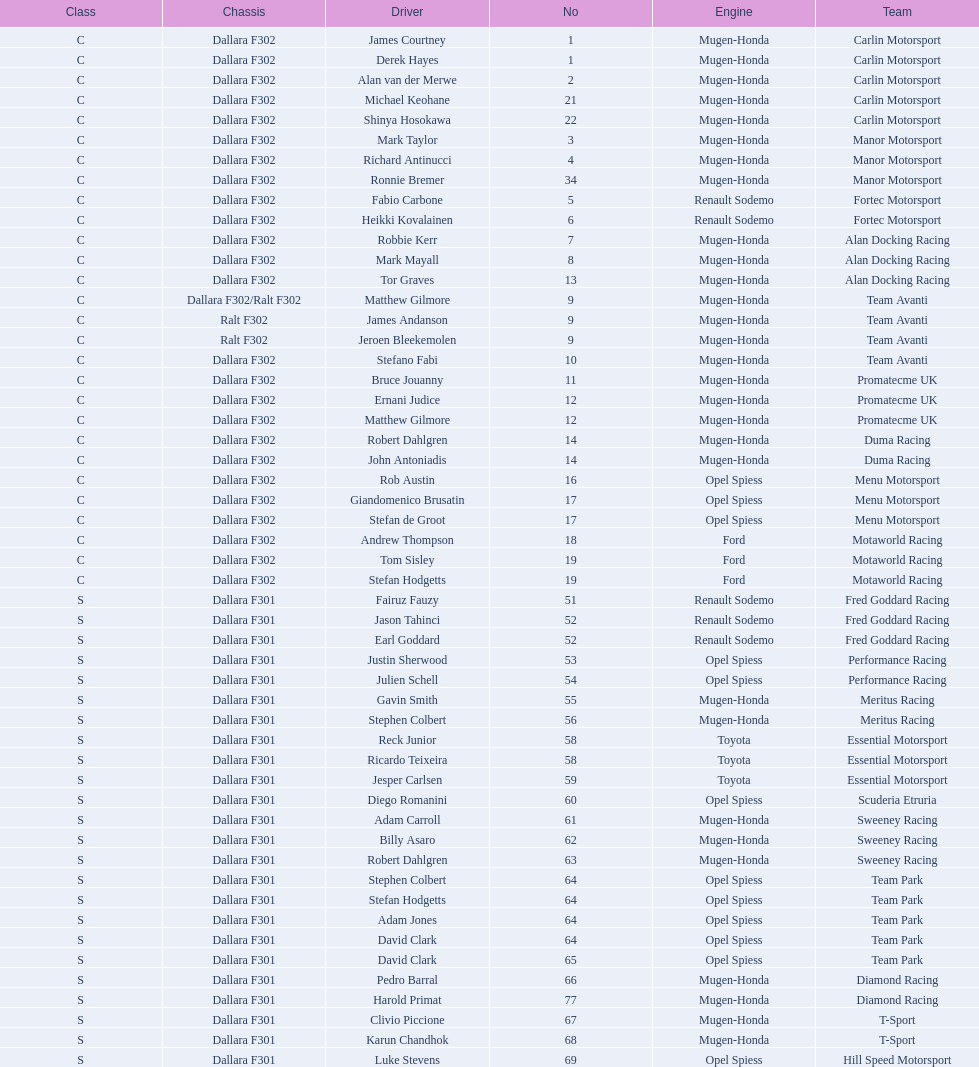On average, how many teams were equipped with a mugen-honda engine? 24. 